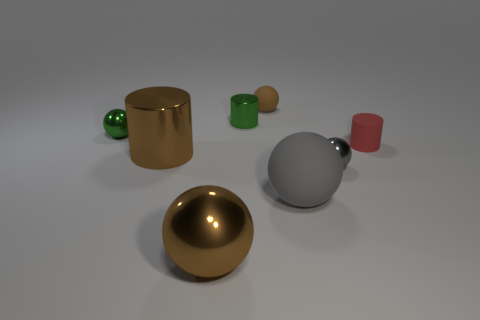Subtract 2 balls. How many balls are left? 3 Subtract all gray rubber balls. How many balls are left? 4 Subtract all cyan spheres. Subtract all cyan cubes. How many spheres are left? 5 Add 1 large matte objects. How many objects exist? 9 Subtract all cylinders. How many objects are left? 5 Add 6 big shiny objects. How many big shiny objects exist? 8 Subtract 2 gray balls. How many objects are left? 6 Subtract all green spheres. Subtract all shiny objects. How many objects are left? 2 Add 8 brown rubber balls. How many brown rubber balls are left? 9 